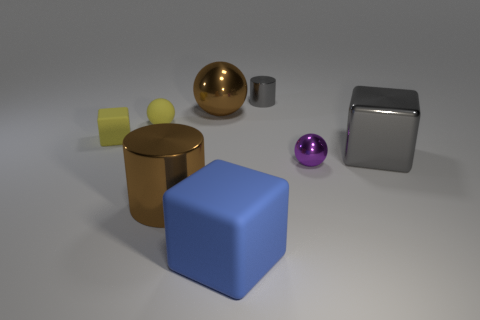Add 1 large metallic cylinders. How many objects exist? 9 Subtract all brown cylinders. How many cylinders are left? 1 Subtract all small blocks. How many blocks are left? 2 Subtract 0 cyan balls. How many objects are left? 8 Subtract all cubes. How many objects are left? 5 Subtract 3 blocks. How many blocks are left? 0 Subtract all blue spheres. Subtract all cyan cubes. How many spheres are left? 3 Subtract all purple cubes. How many brown cylinders are left? 1 Subtract all small green matte balls. Subtract all tiny purple objects. How many objects are left? 7 Add 6 blue cubes. How many blue cubes are left? 7 